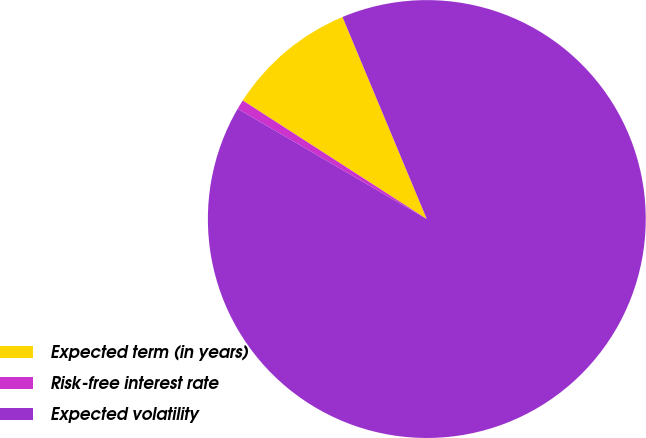<chart> <loc_0><loc_0><loc_500><loc_500><pie_chart><fcel>Expected term (in years)<fcel>Risk-free interest rate<fcel>Expected volatility<nl><fcel>9.6%<fcel>0.71%<fcel>89.69%<nl></chart> 